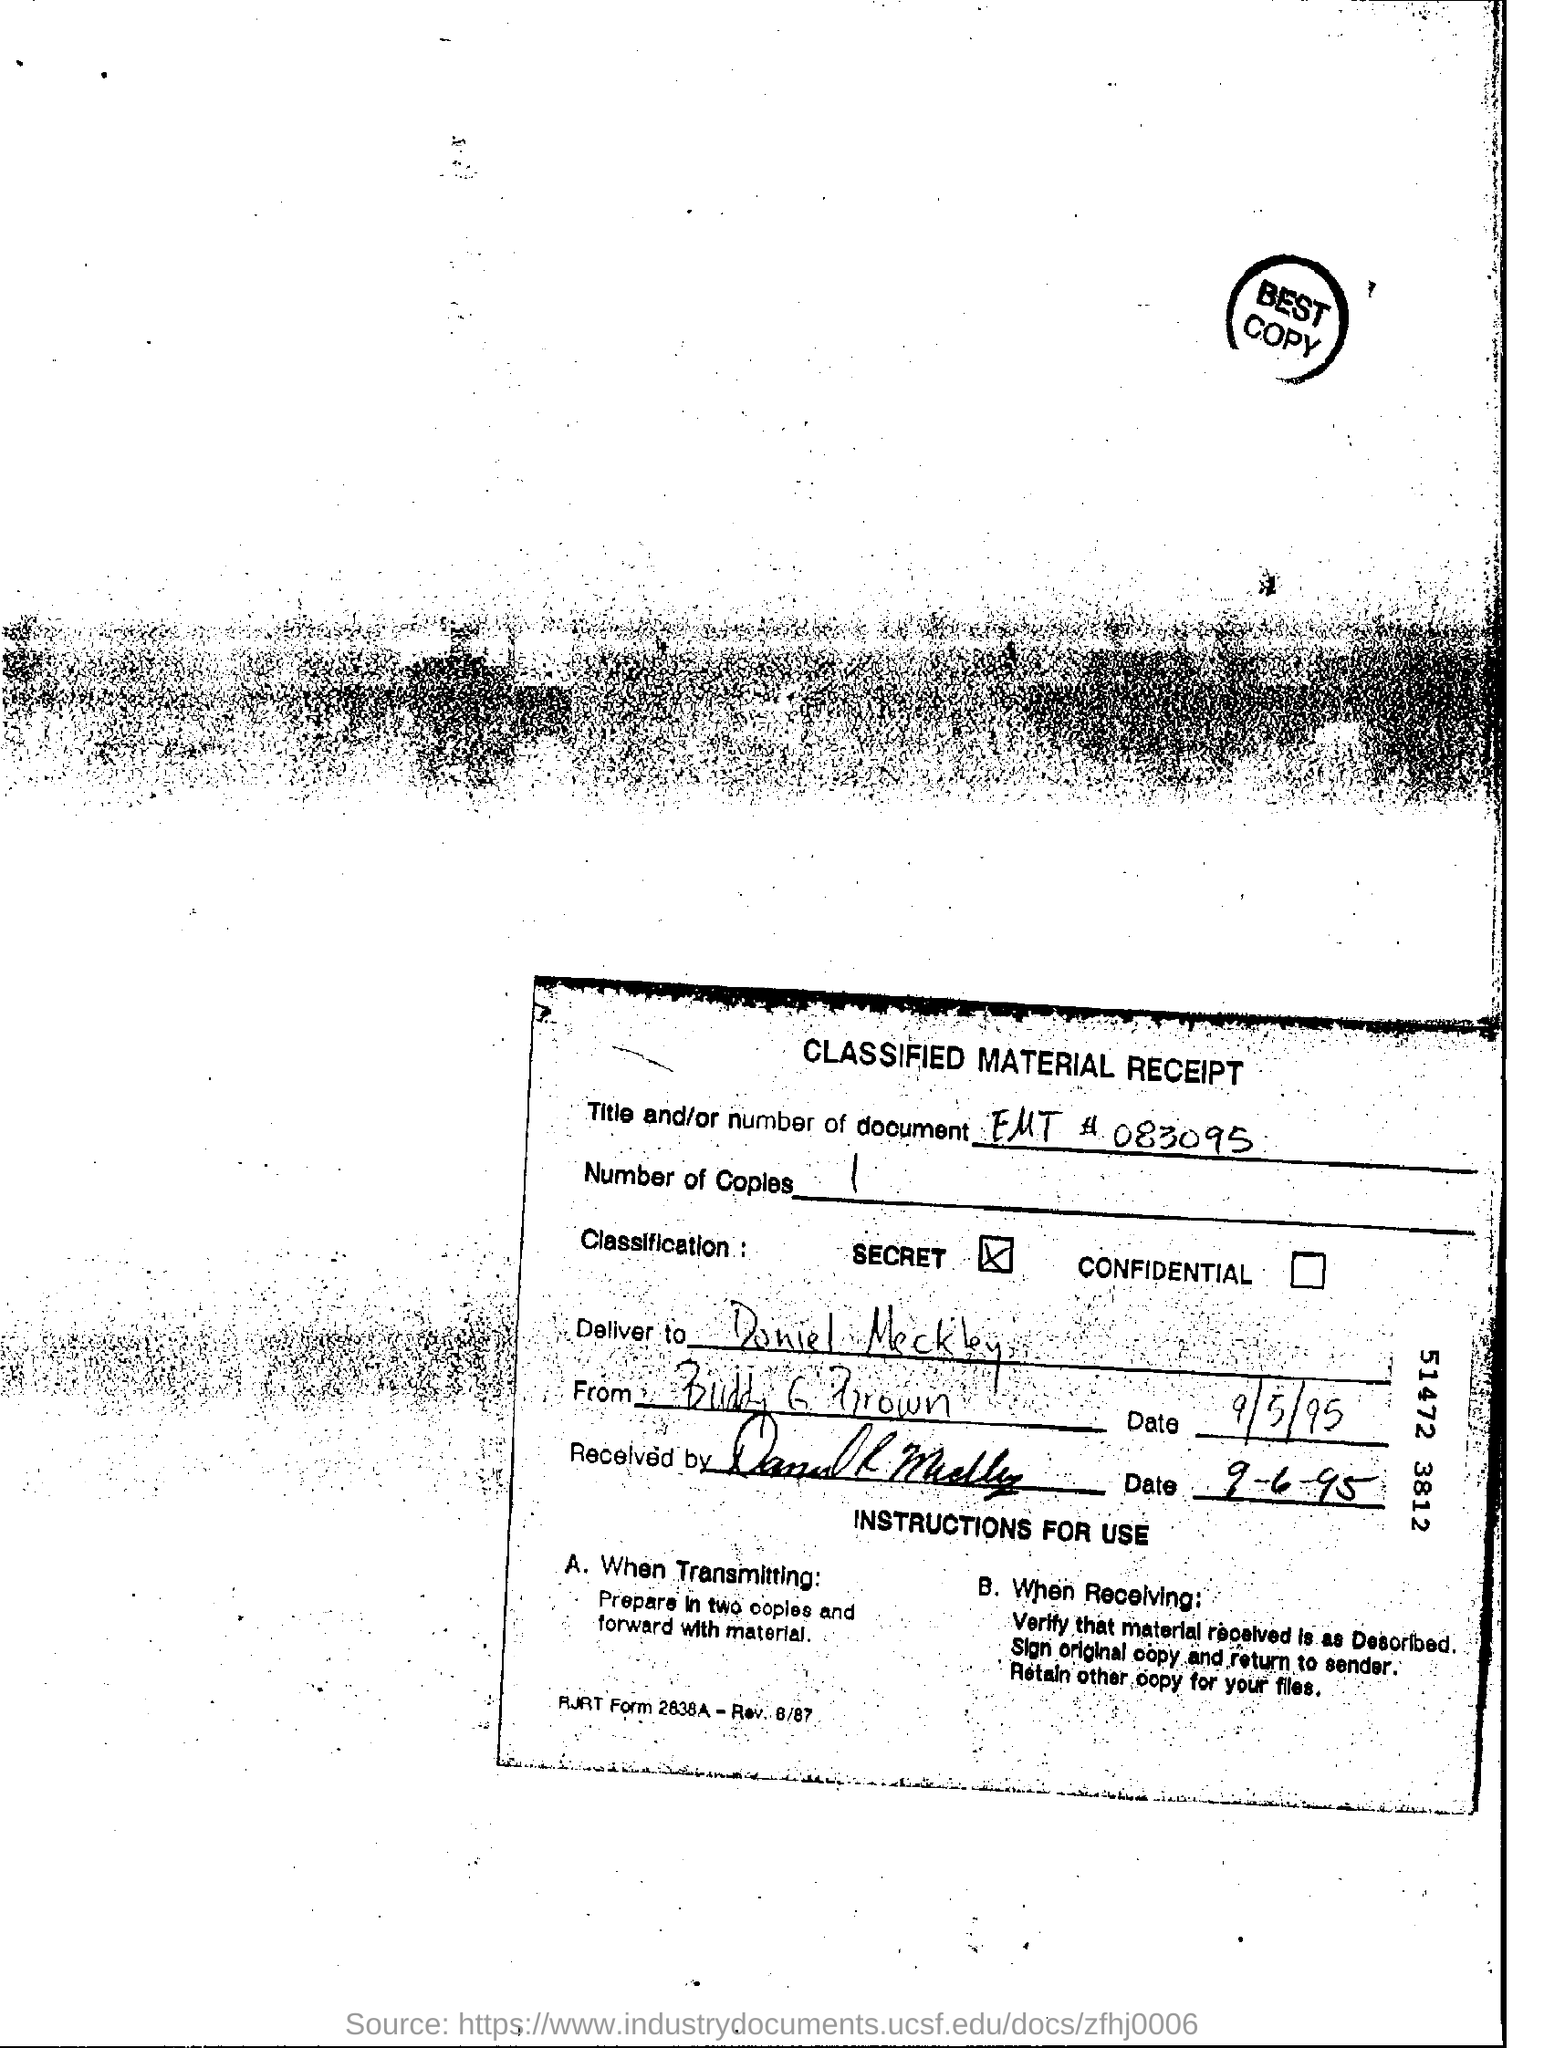What is the Title of the document?
Make the answer very short. Classified Material Receipt. What is the Title and/or number of document?
Provide a succinct answer. EMT # 083095. How many Number of copies?
Your response must be concise. 1. Who should it be delivered to?
Your response must be concise. Daniel Meckley. Who is it From?
Your answer should be very brief. Buddy G Brown. What date was it sent?
Provide a succinct answer. 9-5-95. What date was it received?
Your answer should be compact. 9-6-95. When to Prepare in two copies and forward with material?
Your answer should be very brief. When transmitting. 